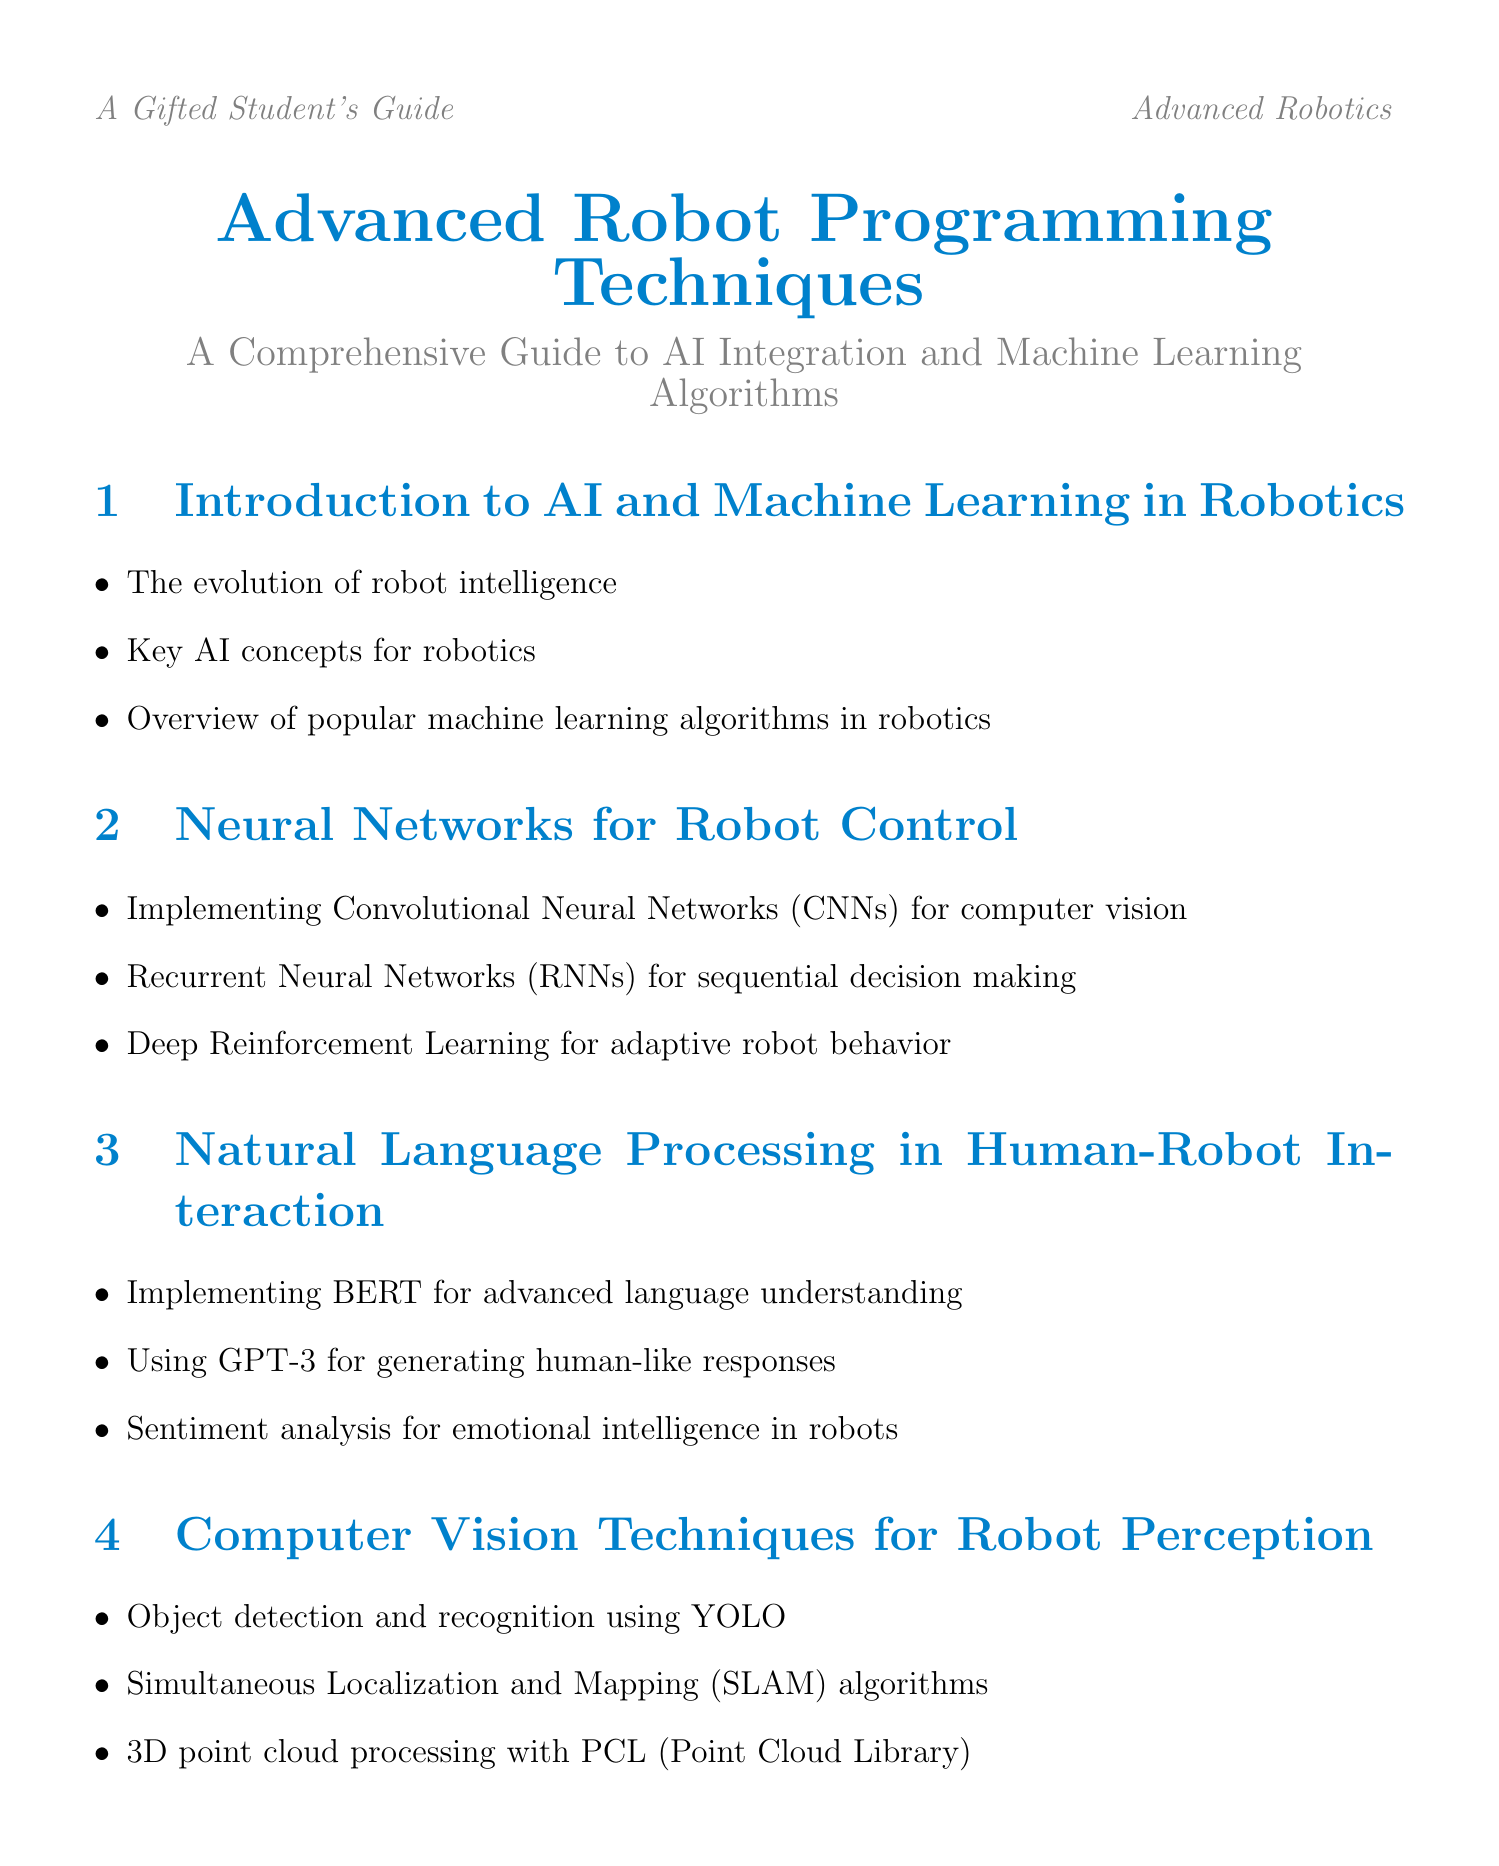What is the title of the document? The title is presented at the beginning of the document and is “Advanced Robot Programming Techniques: A Comprehensive Guide to AI Integration and Machine Learning Algorithms.”
Answer: Advanced Robot Programming Techniques: A Comprehensive Guide to AI Integration and Machine Learning Algorithms How many chapters are there in the document? The number of chapters can be counted in the table of contents, which lists them explicitly. There are 10 chapters in total.
Answer: 10 What algorithm is used for simultaneous localization and mapping? This information is found in the section detailing computer vision techniques. The document mentions “SLAM algorithms” for this purpose.
Answer: SLAM algorithms Which framework is mentioned for neural network implementation? The section on machine learning libraries specifies that TensorFlow and Keras are used for neural network implementation.
Answer: TensorFlow and Keras What ethical consideration is highlighted in the document? The ethics section discusses multiple considerations, one of which is “privacy considerations in data collection and processing.”
Answer: Privacy considerations in data collection and processing Which autonomous system is analyzed in the case studies? The case studies section includes an analysis of Boston Dynamics' robots, specifically mentioning “Boston Dynamics' Spot and Atlas robots.”
Answer: Boston Dynamics' Spot and Atlas robots What is one of the creative design tips mentioned? The document lists creative design tips specifically for gifted students, one of which includes “incorporating biomimicry in robot design for enhanced efficiency.”
Answer: Incorporating biomimicry in robot design for enhanced efficiency What emerging technology is discussed in the future trends chapter? The future trends chapter mentions multiple technologies, including “quantum computing applications in robotics.”
Answer: Quantum computing applications in robotics What does Appendix B focus on? Appendix B is focused on competitions and hackathons in robotics, providing a list of prestigious events along with strategies for success.
Answer: Robotics competitions and hackathons 